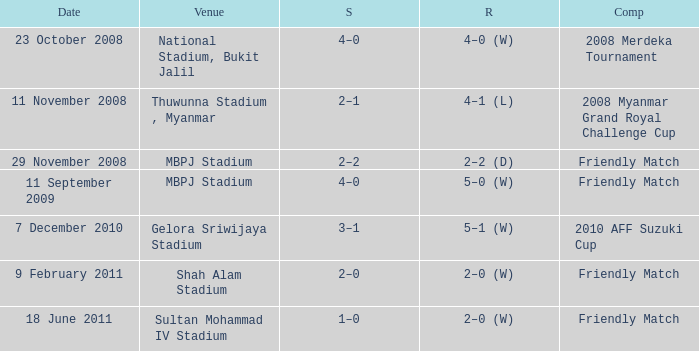What is the Venue of the Competition with a Result of 2–2 (d)? MBPJ Stadium. 